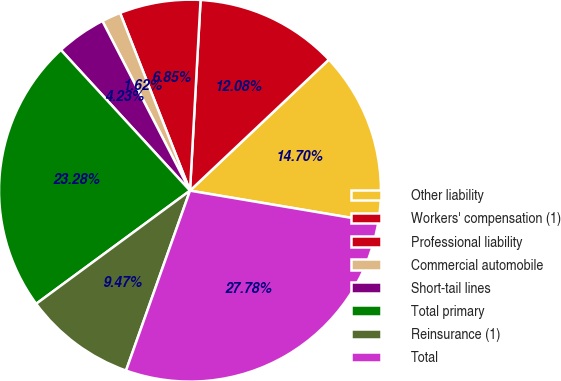<chart> <loc_0><loc_0><loc_500><loc_500><pie_chart><fcel>Other liability<fcel>Workers' compensation (1)<fcel>Professional liability<fcel>Commercial automobile<fcel>Short-tail lines<fcel>Total primary<fcel>Reinsurance (1)<fcel>Total<nl><fcel>14.7%<fcel>12.08%<fcel>6.85%<fcel>1.62%<fcel>4.23%<fcel>23.28%<fcel>9.47%<fcel>27.78%<nl></chart> 